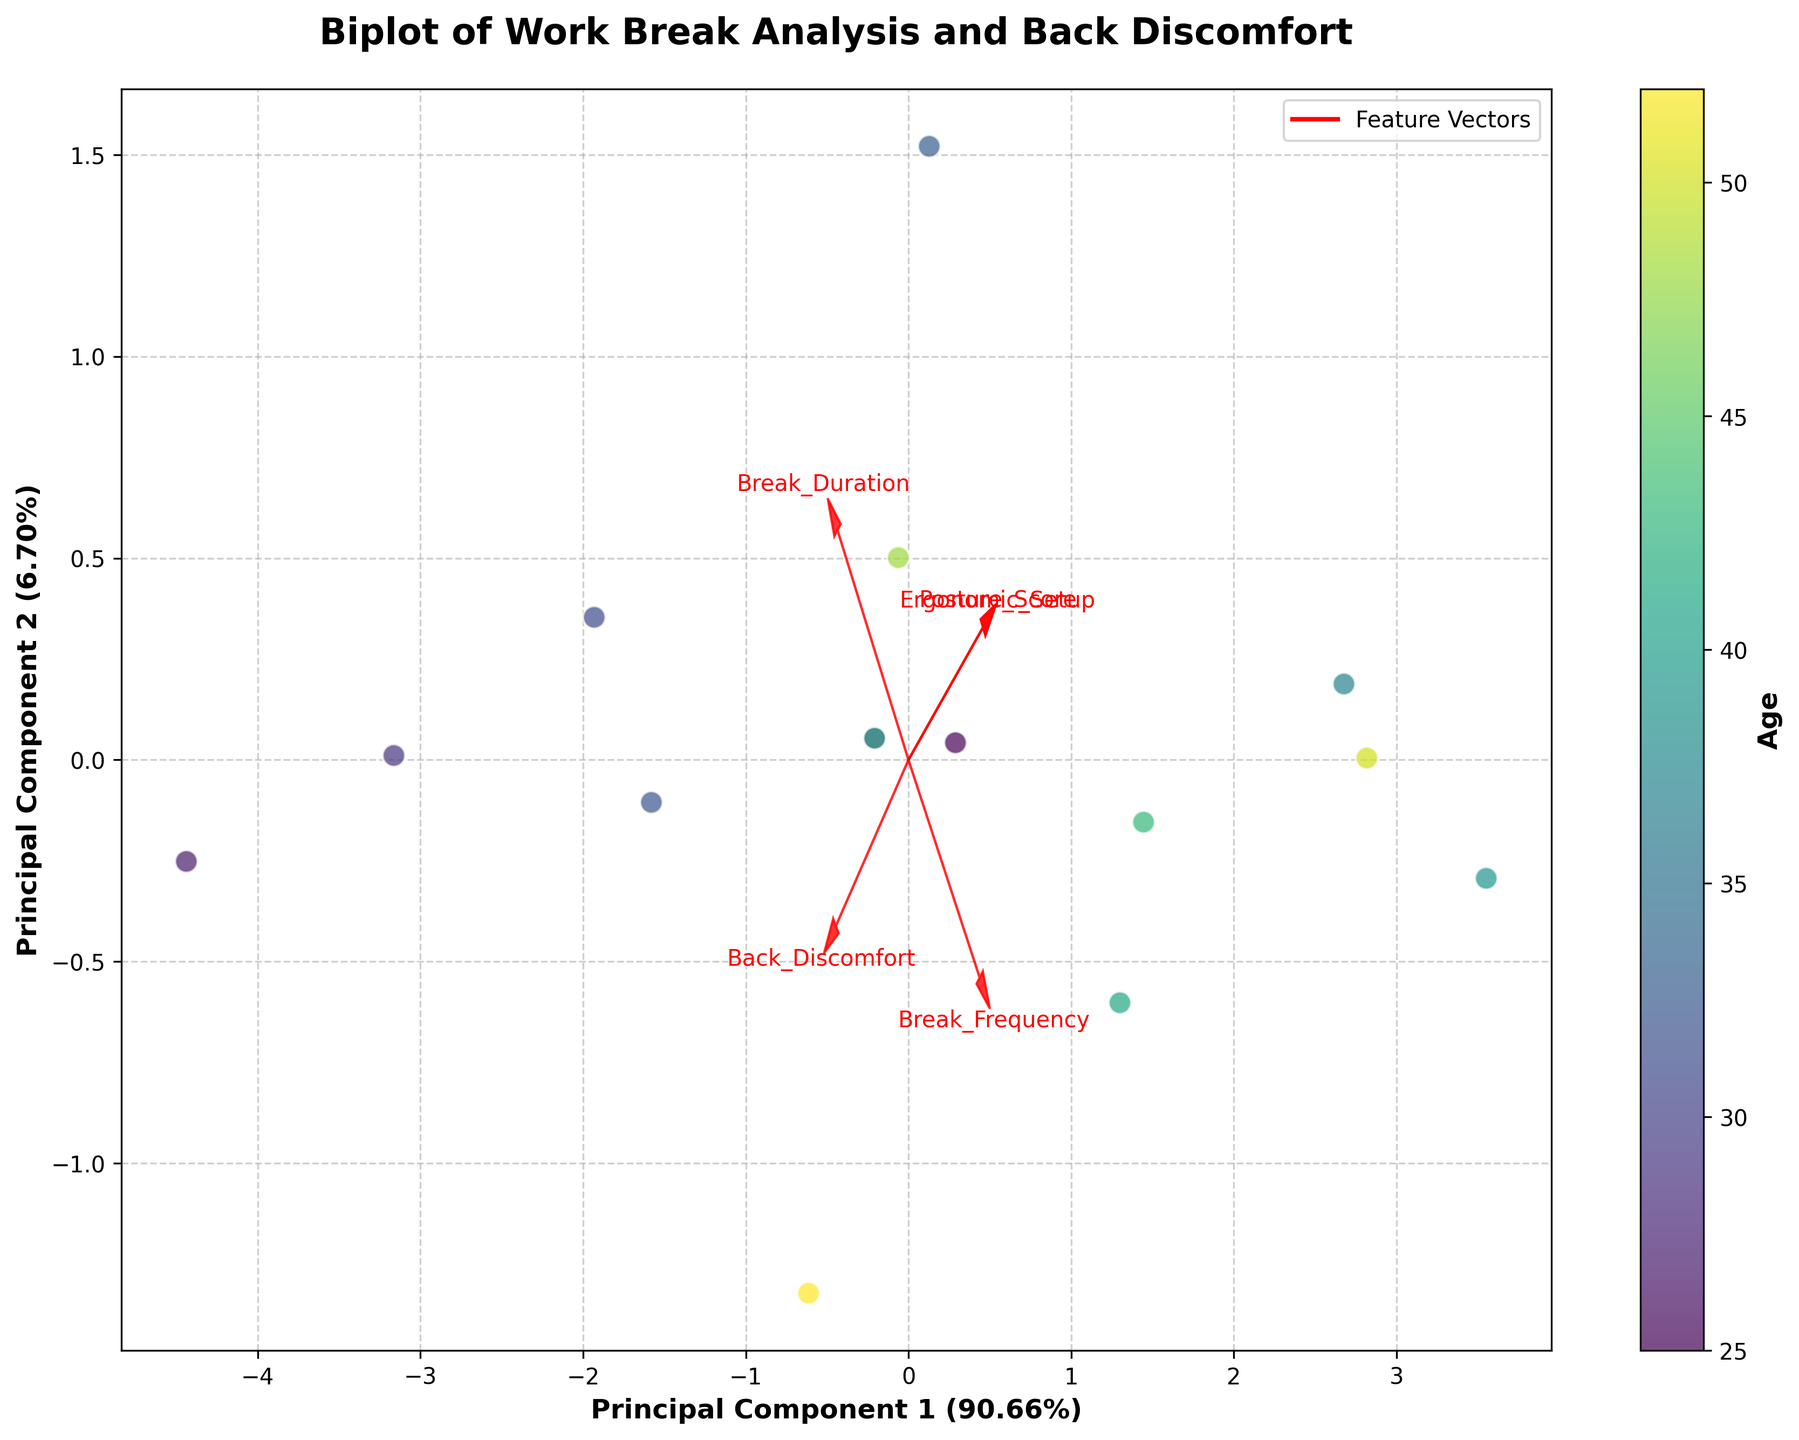How many principal components are displayed in the biplot? The biplot displays two principal components, which are denoted by the x-axis and y-axis labeled with 'Principal Component 1' and 'Principal Component 2'.
Answer: Two What does the color of the data points represent? The color of the data points represents the age of the designers. This is indicated by the color scale and the label 'Age' on the color bar beside the plot.
Answer: Age Which feature vector is the longest in the plot? To determine the longest feature vector, look at the arrows representing each feature. The 'Posture_Score' has the longest arrow, indicating it has the most significant variance along the principal components.
Answer: Posture_Score Is there a noticeable relationship between 'Break_Frequency' and 'Posture_Score'? To observe the relationship, look at the direction of the arrows for 'Break_Frequency' and 'Posture_Score'. Both arrows point in the same general direction, indicating a positive relationship between the two features.
Answer: Yes Which principal component explains more variance in the data? Examine the x and y-axis labels, which indicate the variance explained by each component. 'Principal Component 1' explains more variance as it has a higher percentage than 'Principal Component 2'.
Answer: Principal Component 1 How does 'Back_Discomfort' relate to 'Ergonomic_Setup'? By observing the arrow directions for 'Back_Discomfort' and 'Ergonomic_Setup', which are nearly opposite, it indicates a negative correlation between these two features.
Answer: Negative correlation Which feature has the smallest impact on Principal Component 1? By looking at the length of the feature vectors projected primarily along Principal Component 1, 'Back_Discomfort' has one of the shortest lengths, suggesting a smaller impact.
Answer: Back_Discomfort What is the general relationship between age and 'Break_Duration'? To find this relationship, compare the direction of the age gradient (color) with the arrow for 'Break_Duration'. There is no strong pattern indicating a direct relationship, suggesting a weak or no significant correlation.
Answer: Weak or no significant correlation 